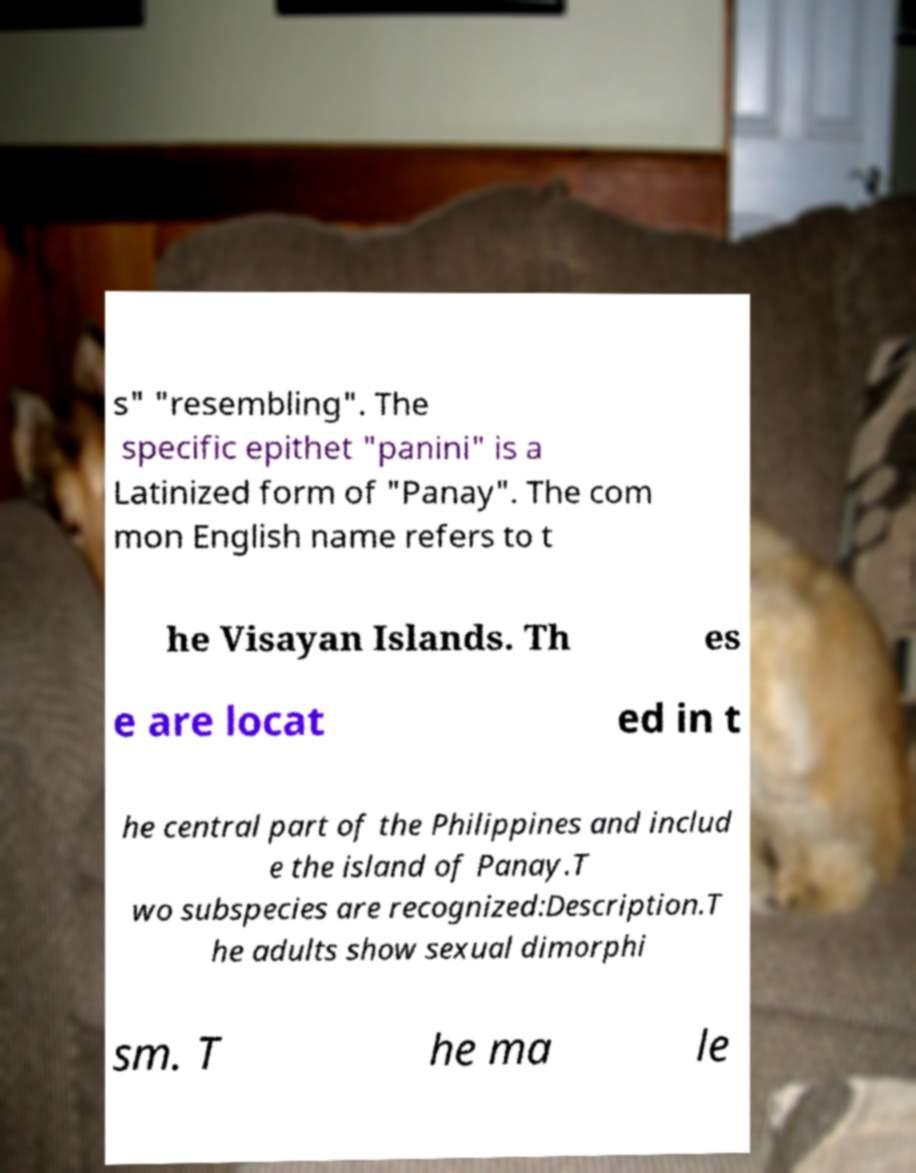Could you assist in decoding the text presented in this image and type it out clearly? s" "resembling". The specific epithet "panini" is a Latinized form of "Panay". The com mon English name refers to t he Visayan Islands. Th es e are locat ed in t he central part of the Philippines and includ e the island of Panay.T wo subspecies are recognized:Description.T he adults show sexual dimorphi sm. T he ma le 